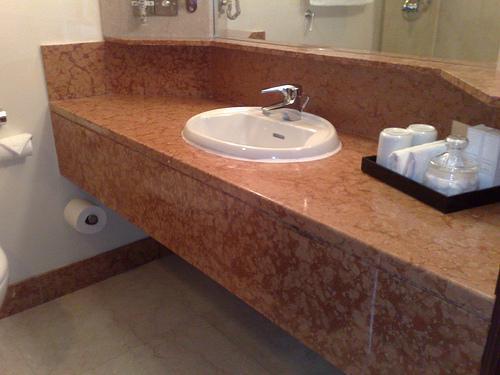How many sinks are there?
Give a very brief answer. 1. 